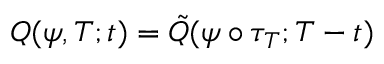<formula> <loc_0><loc_0><loc_500><loc_500>Q ( \psi , T ; t ) = \tilde { Q } ( \psi \circ \tau _ { T } ; T - t )</formula> 